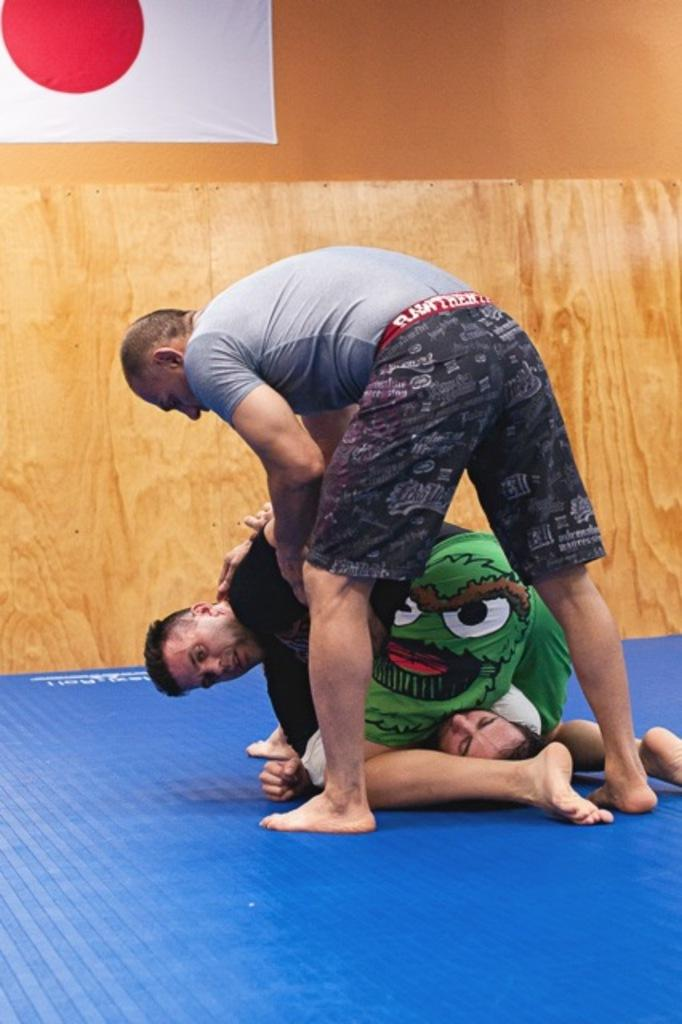What is the main subject of the image? There are persons in the center of the image. What can be seen in the background of the image? There is a wall in the background of the image. What is hanging on the wall in the image? There is a banner hanging on the wall. What colors are used for the banner? The banner is white and red in color. Can you tell me how many turkeys are visible in the image? There are no turkeys present in the image. What type of snake can be seen slithering on the wall in the image? There is no snake present in the image; it only features a banner hanging on the wall. 